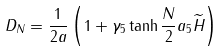Convert formula to latex. <formula><loc_0><loc_0><loc_500><loc_500>D _ { N } = \frac { 1 } { 2 a } \left ( 1 + \gamma _ { 5 } \tanh \frac { N } { 2 } a _ { 5 } \widetilde { H } \right )</formula> 